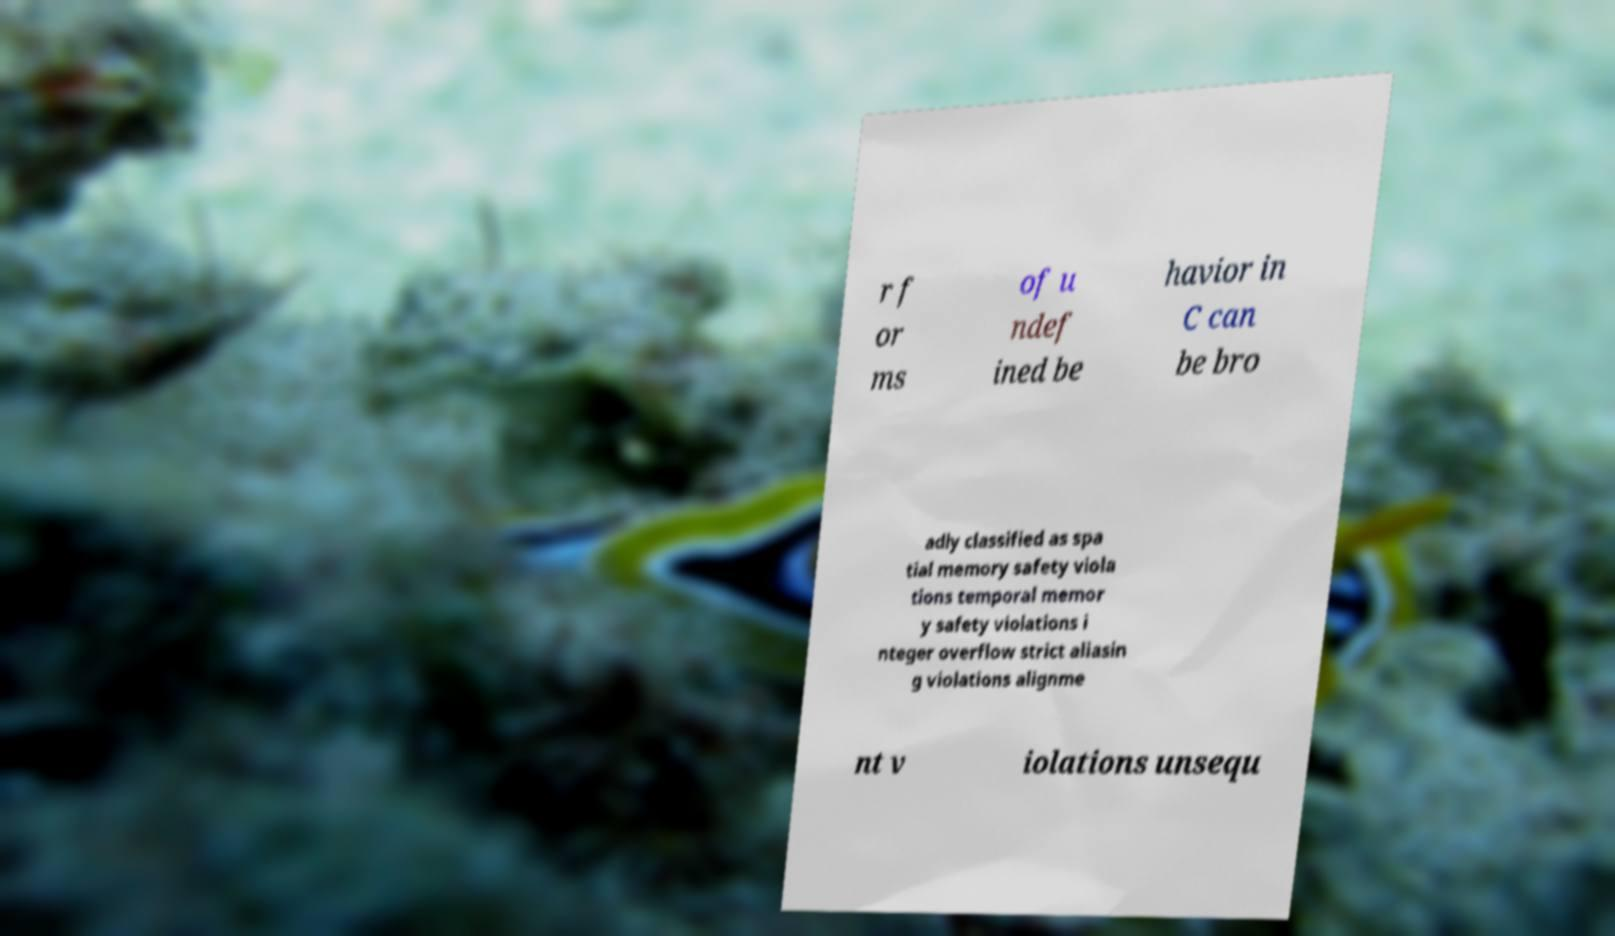What messages or text are displayed in this image? I need them in a readable, typed format. r f or ms of u ndef ined be havior in C can be bro adly classified as spa tial memory safety viola tions temporal memor y safety violations i nteger overflow strict aliasin g violations alignme nt v iolations unsequ 